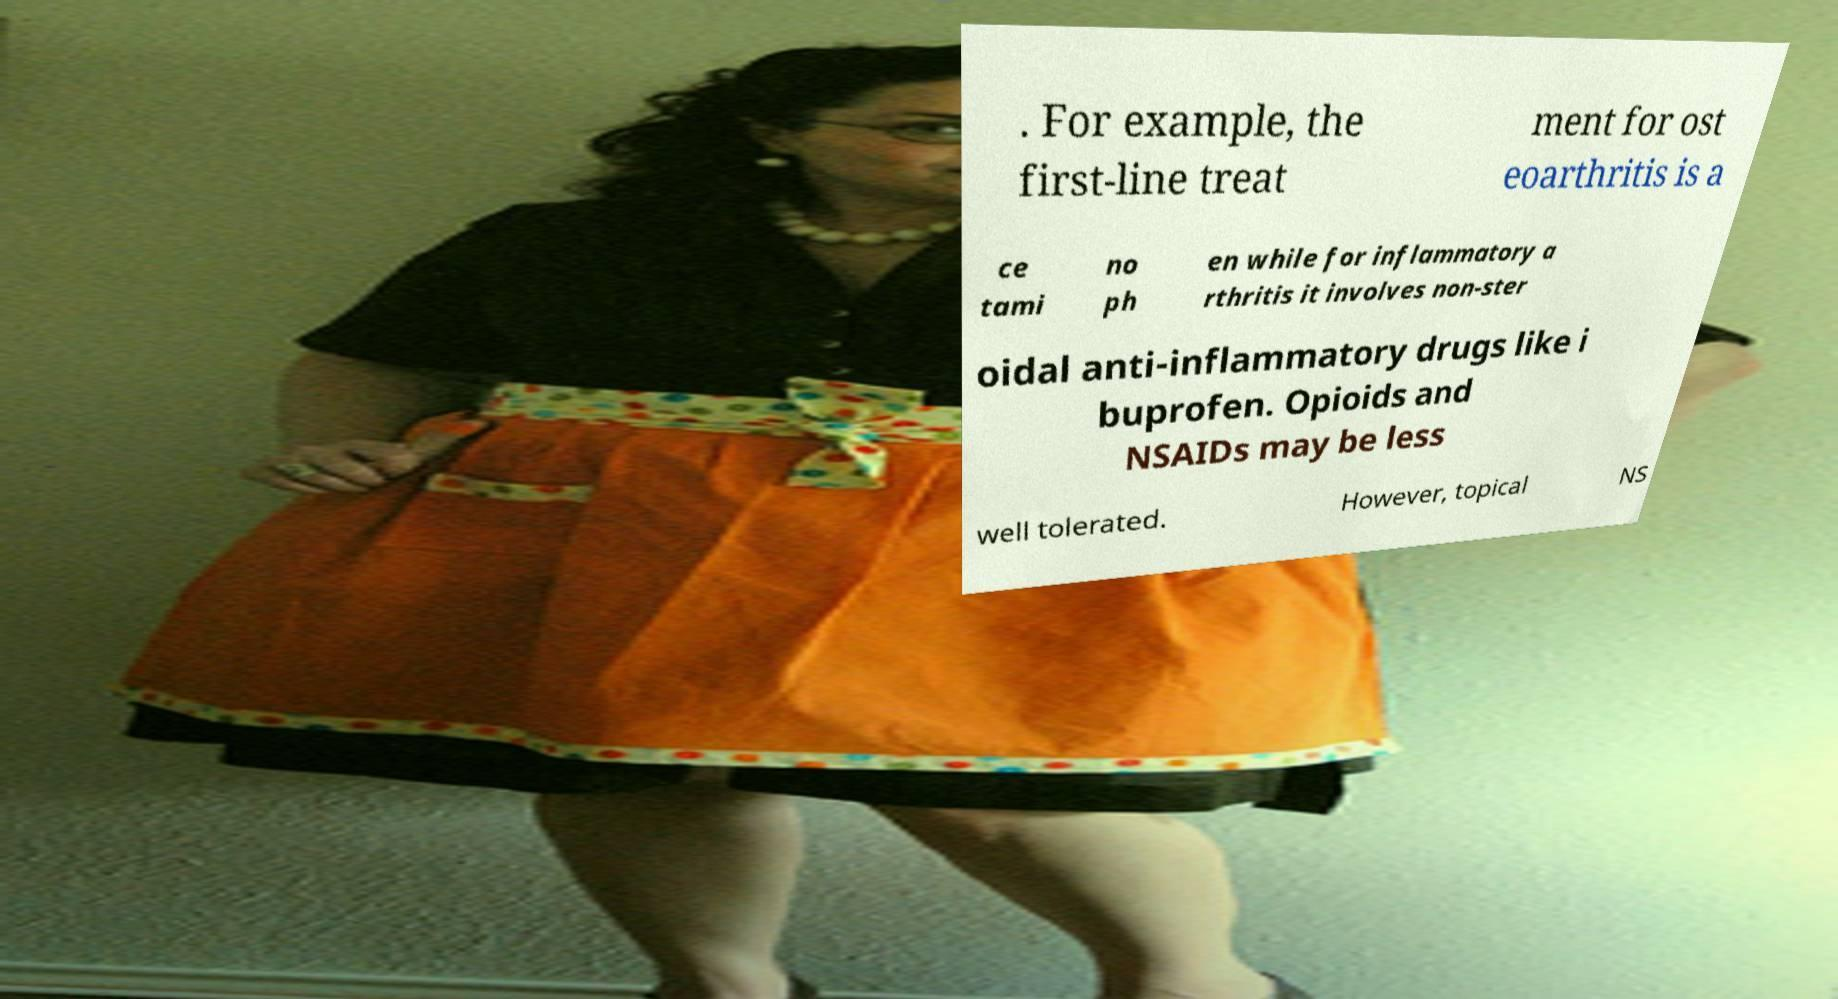What messages or text are displayed in this image? I need them in a readable, typed format. . For example, the first-line treat ment for ost eoarthritis is a ce tami no ph en while for inflammatory a rthritis it involves non-ster oidal anti-inflammatory drugs like i buprofen. Opioids and NSAIDs may be less well tolerated. However, topical NS 